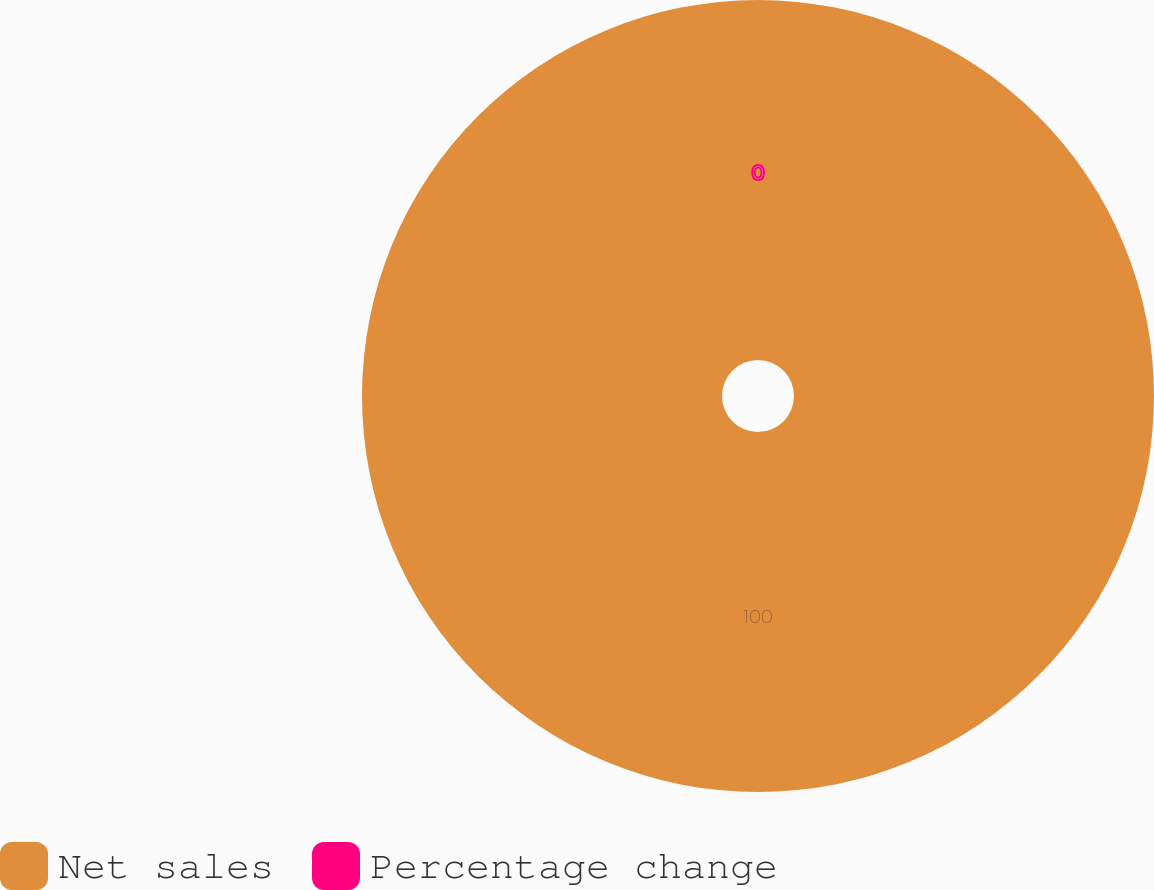Convert chart to OTSL. <chart><loc_0><loc_0><loc_500><loc_500><pie_chart><fcel>Net sales<fcel>Percentage change<nl><fcel>100.0%<fcel>0.0%<nl></chart> 